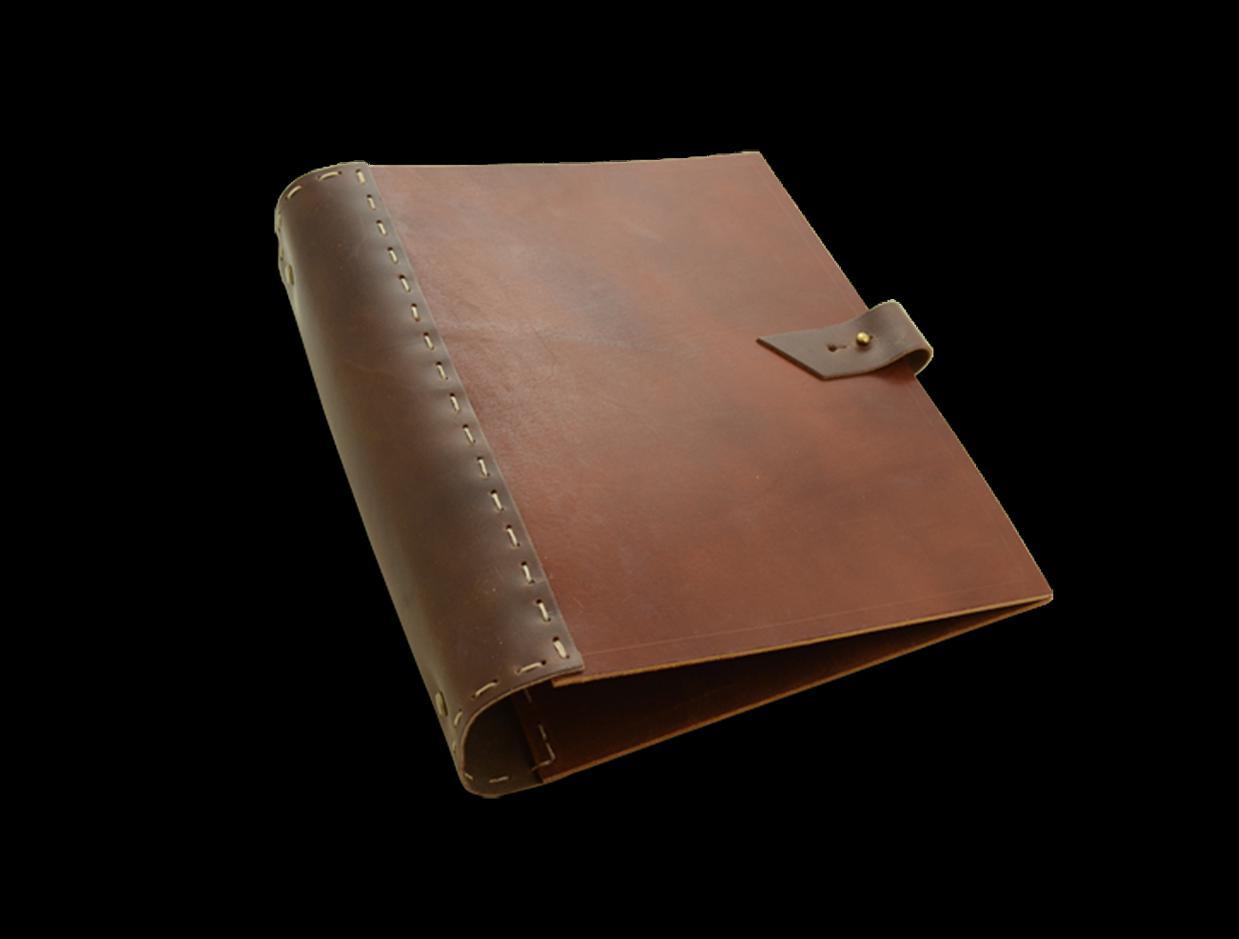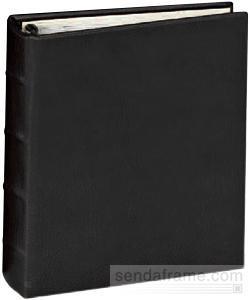The first image is the image on the left, the second image is the image on the right. For the images displayed, is the sentence "Left image shows an open binder with paper in it." factually correct? Answer yes or no. No. The first image is the image on the left, the second image is the image on the right. For the images displayed, is the sentence "One image shows a leather notebook both opened and closed, while the second image shows one or more notebooks, but only one opened." factually correct? Answer yes or no. No. 